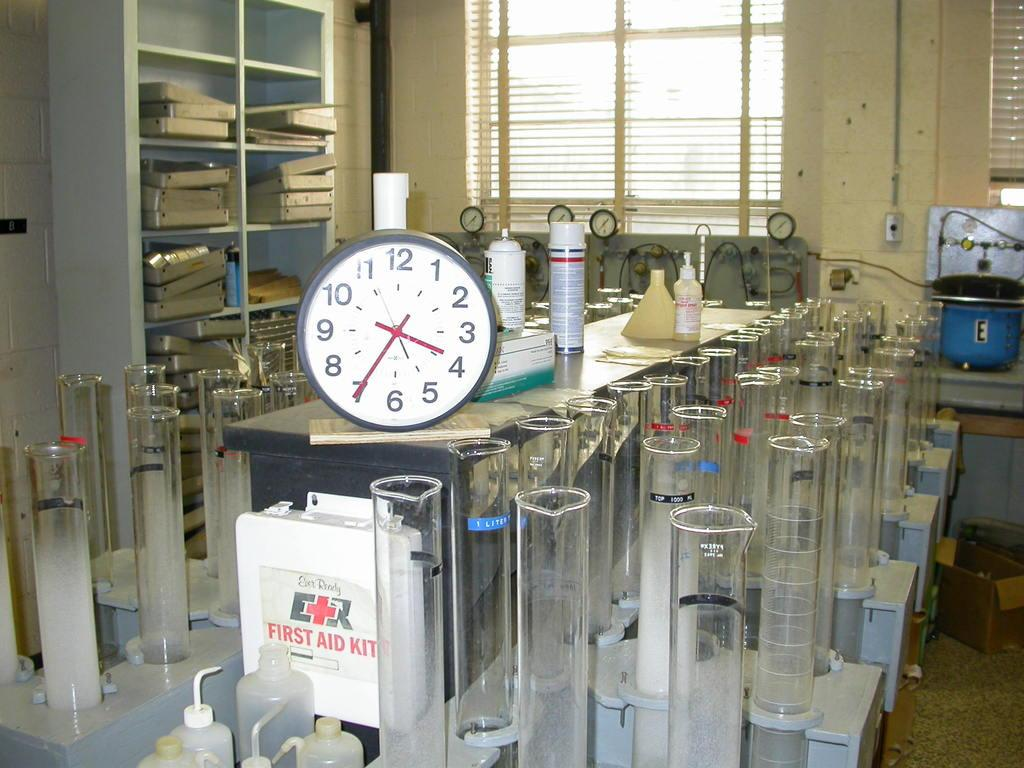<image>
Render a clear and concise summary of the photo. A white box labeled First Aid Kit is on a table below a clock. 